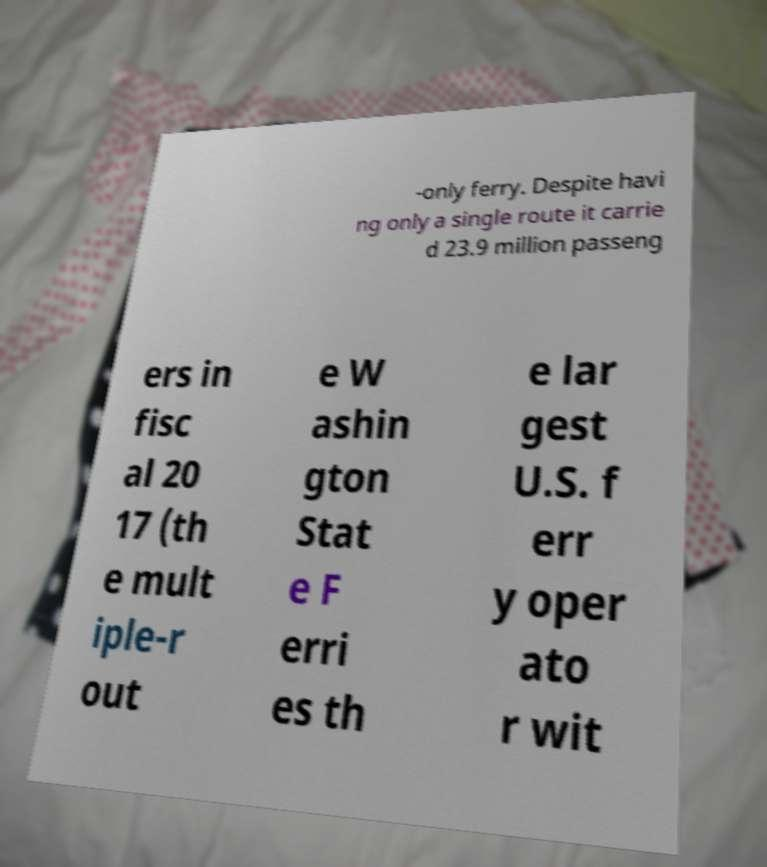Can you read and provide the text displayed in the image?This photo seems to have some interesting text. Can you extract and type it out for me? -only ferry. Despite havi ng only a single route it carrie d 23.9 million passeng ers in fisc al 20 17 (th e mult iple-r out e W ashin gton Stat e F erri es th e lar gest U.S. f err y oper ato r wit 